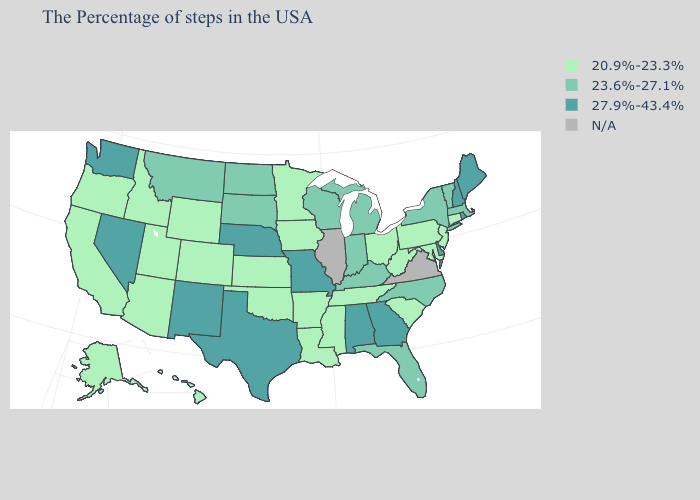What is the value of Delaware?
Short answer required. 27.9%-43.4%. Name the states that have a value in the range 23.6%-27.1%?
Keep it brief. Massachusetts, Vermont, New York, North Carolina, Florida, Michigan, Kentucky, Indiana, Wisconsin, South Dakota, North Dakota, Montana. What is the highest value in states that border New Hampshire?
Be succinct. 27.9%-43.4%. What is the lowest value in the USA?
Quick response, please. 20.9%-23.3%. Is the legend a continuous bar?
Quick response, please. No. What is the highest value in the Northeast ?
Quick response, please. 27.9%-43.4%. Which states have the lowest value in the USA?
Give a very brief answer. Connecticut, New Jersey, Maryland, Pennsylvania, South Carolina, West Virginia, Ohio, Tennessee, Mississippi, Louisiana, Arkansas, Minnesota, Iowa, Kansas, Oklahoma, Wyoming, Colorado, Utah, Arizona, Idaho, California, Oregon, Alaska, Hawaii. Among the states that border Pennsylvania , which have the highest value?
Keep it brief. Delaware. Name the states that have a value in the range 20.9%-23.3%?
Answer briefly. Connecticut, New Jersey, Maryland, Pennsylvania, South Carolina, West Virginia, Ohio, Tennessee, Mississippi, Louisiana, Arkansas, Minnesota, Iowa, Kansas, Oklahoma, Wyoming, Colorado, Utah, Arizona, Idaho, California, Oregon, Alaska, Hawaii. Name the states that have a value in the range 23.6%-27.1%?
Answer briefly. Massachusetts, Vermont, New York, North Carolina, Florida, Michigan, Kentucky, Indiana, Wisconsin, South Dakota, North Dakota, Montana. Name the states that have a value in the range 23.6%-27.1%?
Write a very short answer. Massachusetts, Vermont, New York, North Carolina, Florida, Michigan, Kentucky, Indiana, Wisconsin, South Dakota, North Dakota, Montana. Name the states that have a value in the range 20.9%-23.3%?
Short answer required. Connecticut, New Jersey, Maryland, Pennsylvania, South Carolina, West Virginia, Ohio, Tennessee, Mississippi, Louisiana, Arkansas, Minnesota, Iowa, Kansas, Oklahoma, Wyoming, Colorado, Utah, Arizona, Idaho, California, Oregon, Alaska, Hawaii. What is the highest value in states that border Oregon?
Give a very brief answer. 27.9%-43.4%. Does the map have missing data?
Quick response, please. Yes. Name the states that have a value in the range 27.9%-43.4%?
Write a very short answer. Maine, Rhode Island, New Hampshire, Delaware, Georgia, Alabama, Missouri, Nebraska, Texas, New Mexico, Nevada, Washington. 